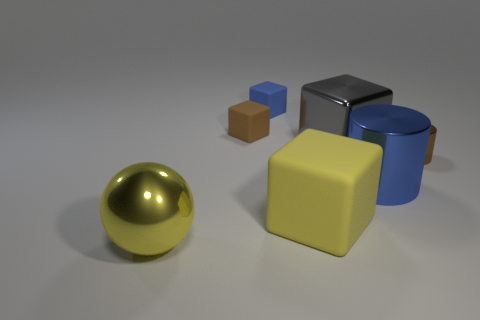Add 2 tiny purple rubber spheres. How many objects exist? 9 Subtract all small brown blocks. How many blocks are left? 3 Subtract all gray blocks. How many blocks are left? 3 Subtract all spheres. How many objects are left? 6 Add 2 small brown matte cubes. How many small brown matte cubes exist? 3 Subtract 1 blue cubes. How many objects are left? 6 Subtract all green cylinders. Subtract all red spheres. How many cylinders are left? 2 Subtract all green balls. How many brown cylinders are left? 1 Subtract all big purple shiny cylinders. Subtract all blue things. How many objects are left? 5 Add 4 rubber blocks. How many rubber blocks are left? 7 